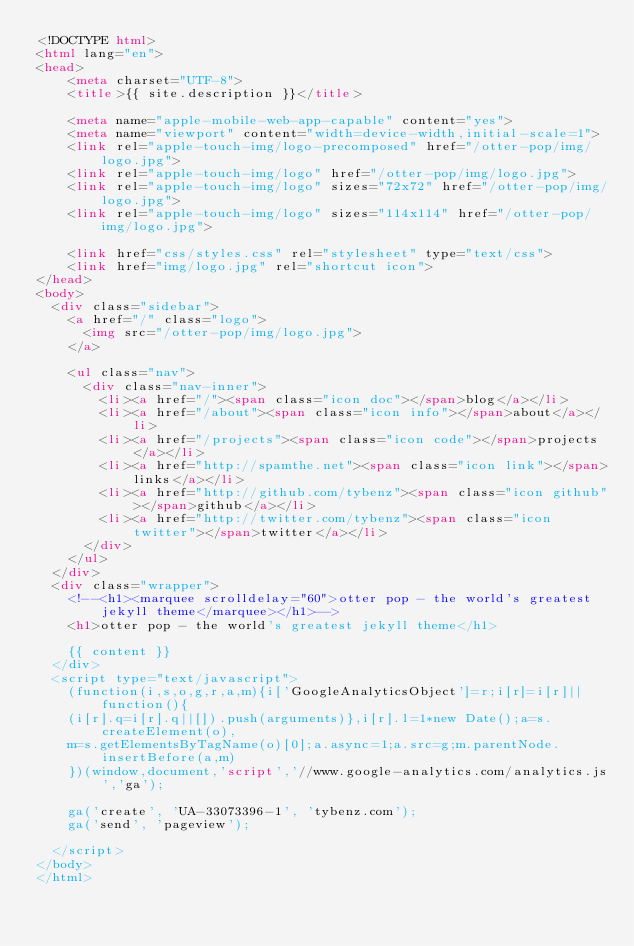Convert code to text. <code><loc_0><loc_0><loc_500><loc_500><_HTML_><!DOCTYPE html>
<html lang="en">
<head>
    <meta charset="UTF-8">
    <title>{{ site.description }}</title>

    <meta name="apple-mobile-web-app-capable" content="yes">
    <meta name="viewport" content="width=device-width,initial-scale=1">
    <link rel="apple-touch-img/logo-precomposed" href="/otter-pop/img/logo.jpg">
    <link rel="apple-touch-img/logo" href="/otter-pop/img/logo.jpg">
    <link rel="apple-touch-img/logo" sizes="72x72" href="/otter-pop/img/logo.jpg">
    <link rel="apple-touch-img/logo" sizes="114x114" href="/otter-pop/img/logo.jpg">

    <link href="css/styles.css" rel="stylesheet" type="text/css">
    <link href="img/logo.jpg" rel="shortcut icon">
</head>
<body>
  <div class="sidebar">
    <a href="/" class="logo">
      <img src="/otter-pop/img/logo.jpg">
    </a>

    <ul class="nav">
      <div class="nav-inner">
        <li><a href="/"><span class="icon doc"></span>blog</a></li>
        <li><a href="/about"><span class="icon info"></span>about</a></li>
        <li><a href="/projects"><span class="icon code"></span>projects</a></li>
        <li><a href="http://spamthe.net"><span class="icon link"></span>links</a></li>
        <li><a href="http://github.com/tybenz"><span class="icon github"></span>github</a></li>
        <li><a href="http://twitter.com/tybenz"><span class="icon twitter"></span>twitter</a></li>
      </div>
    </ul>
  </div>
  <div class="wrapper">
    <!--<h1><marquee scrolldelay="60">otter pop - the world's greatest jekyll theme</marquee></h1>-->
    <h1>otter pop - the world's greatest jekyll theme</h1>

    {{ content }}
  </div>
  <script type="text/javascript">
    (function(i,s,o,g,r,a,m){i['GoogleAnalyticsObject']=r;i[r]=i[r]||function(){
    (i[r].q=i[r].q||[]).push(arguments)},i[r].l=1*new Date();a=s.createElement(o),
    m=s.getElementsByTagName(o)[0];a.async=1;a.src=g;m.parentNode.insertBefore(a,m)
    })(window,document,'script','//www.google-analytics.com/analytics.js','ga');

    ga('create', 'UA-33073396-1', 'tybenz.com');
    ga('send', 'pageview');

  </script>
</body>
</html>
</code> 